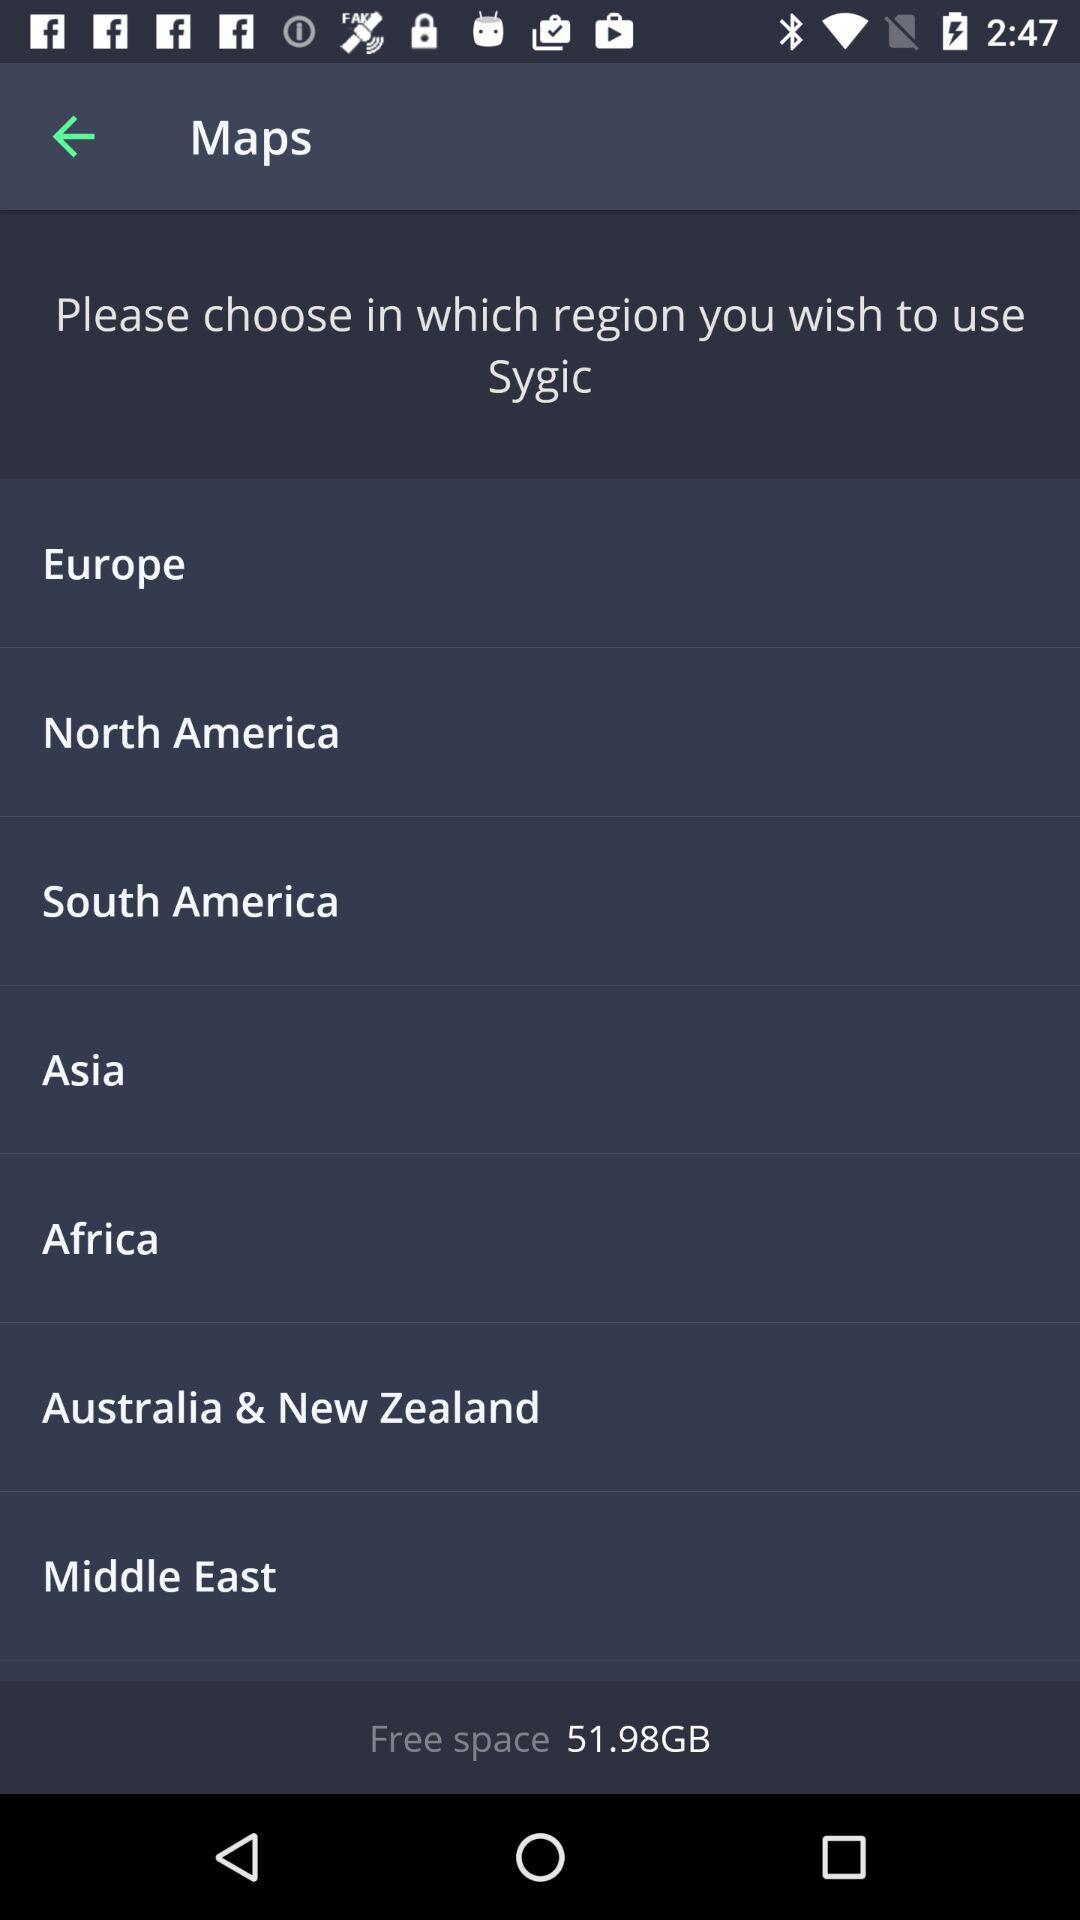How much free space is available on the device?
Answer the question using a single word or phrase. 51.98GB 